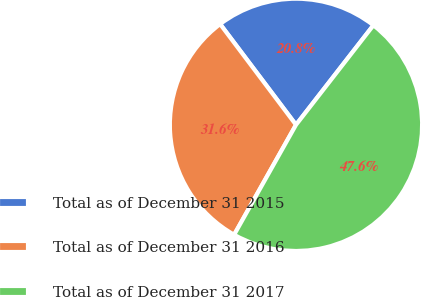Convert chart. <chart><loc_0><loc_0><loc_500><loc_500><pie_chart><fcel>Total as of December 31 2015<fcel>Total as of December 31 2016<fcel>Total as of December 31 2017<nl><fcel>20.79%<fcel>31.57%<fcel>47.64%<nl></chart> 